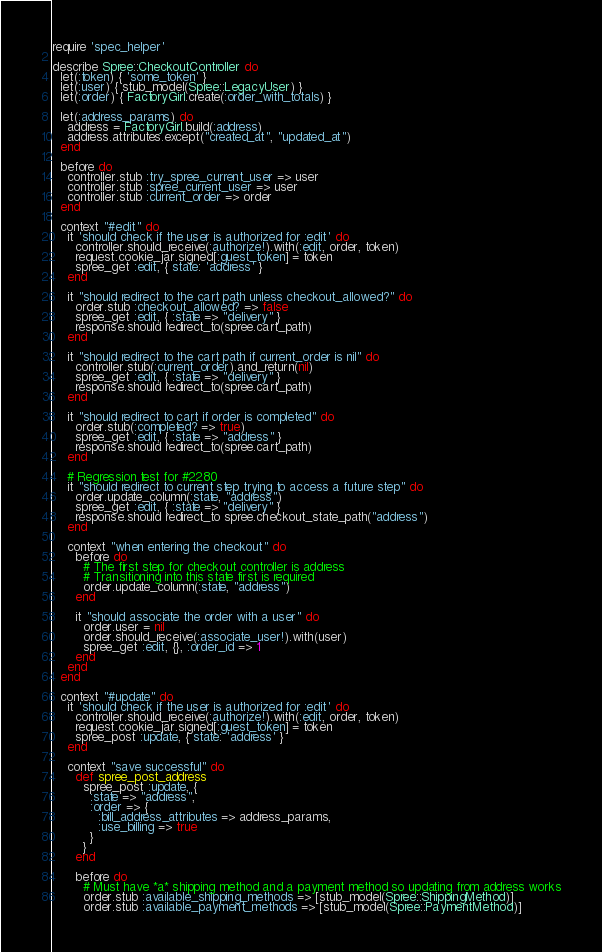Convert code to text. <code><loc_0><loc_0><loc_500><loc_500><_Ruby_>require 'spec_helper'

describe Spree::CheckoutController do
  let(:token) { 'some_token' }
  let(:user) { stub_model(Spree::LegacyUser) }
  let(:order) { FactoryGirl.create(:order_with_totals) }

  let(:address_params) do
    address = FactoryGirl.build(:address)
    address.attributes.except("created_at", "updated_at")
  end

  before do
    controller.stub :try_spree_current_user => user
    controller.stub :spree_current_user => user
    controller.stub :current_order => order
  end

  context "#edit" do
    it 'should check if the user is authorized for :edit' do
      controller.should_receive(:authorize!).with(:edit, order, token)
      request.cookie_jar.signed[:guest_token] = token
      spree_get :edit, { state: 'address' }
    end

    it "should redirect to the cart path unless checkout_allowed?" do
      order.stub :checkout_allowed? => false
      spree_get :edit, { :state => "delivery" }
      response.should redirect_to(spree.cart_path)
    end

    it "should redirect to the cart path if current_order is nil" do
      controller.stub(:current_order).and_return(nil)
      spree_get :edit, { :state => "delivery" }
      response.should redirect_to(spree.cart_path)
    end

    it "should redirect to cart if order is completed" do
      order.stub(:completed? => true)
      spree_get :edit, { :state => "address" }
      response.should redirect_to(spree.cart_path)
    end

    # Regression test for #2280
    it "should redirect to current step trying to access a future step" do
      order.update_column(:state, "address")
      spree_get :edit, { :state => "delivery" }
      response.should redirect_to spree.checkout_state_path("address")
    end

    context "when entering the checkout" do
      before do
        # The first step for checkout controller is address
        # Transitioning into this state first is required
        order.update_column(:state, "address")
      end

      it "should associate the order with a user" do
        order.user = nil
        order.should_receive(:associate_user!).with(user)
        spree_get :edit, {}, :order_id => 1
      end
    end
  end

  context "#update" do
    it 'should check if the user is authorized for :edit' do
      controller.should_receive(:authorize!).with(:edit, order, token)
      request.cookie_jar.signed[:guest_token] = token
      spree_post :update, { state: 'address' }
    end

    context "save successful" do
      def spree_post_address
        spree_post :update, {
          :state => "address",
          :order => {
            :bill_address_attributes => address_params,
            :use_billing => true
          }
        }
      end

      before do
        # Must have *a* shipping method and a payment method so updating from address works
        order.stub :available_shipping_methods => [stub_model(Spree::ShippingMethod)]
        order.stub :available_payment_methods => [stub_model(Spree::PaymentMethod)]</code> 